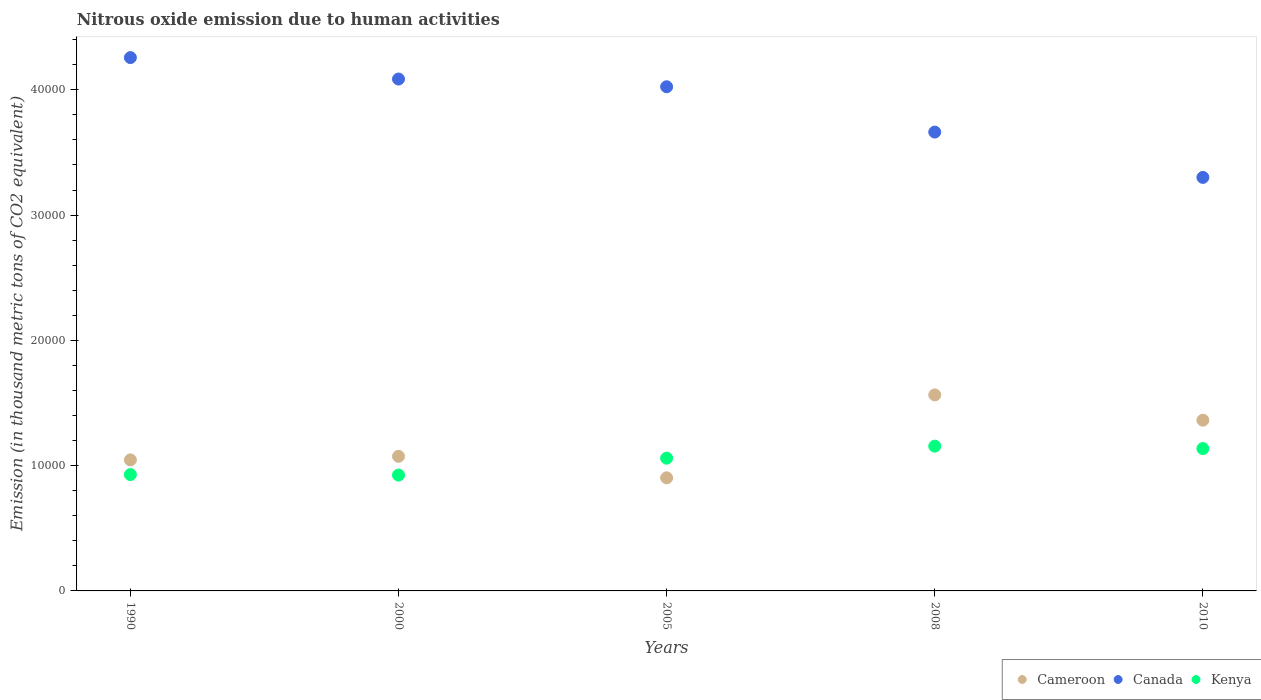Is the number of dotlines equal to the number of legend labels?
Offer a very short reply. Yes. What is the amount of nitrous oxide emitted in Kenya in 2005?
Your response must be concise. 1.06e+04. Across all years, what is the maximum amount of nitrous oxide emitted in Cameroon?
Give a very brief answer. 1.56e+04. Across all years, what is the minimum amount of nitrous oxide emitted in Canada?
Give a very brief answer. 3.30e+04. In which year was the amount of nitrous oxide emitted in Cameroon maximum?
Provide a succinct answer. 2008. In which year was the amount of nitrous oxide emitted in Kenya minimum?
Your response must be concise. 2000. What is the total amount of nitrous oxide emitted in Canada in the graph?
Offer a terse response. 1.93e+05. What is the difference between the amount of nitrous oxide emitted in Canada in 1990 and that in 2008?
Provide a short and direct response. 5946.6. What is the difference between the amount of nitrous oxide emitted in Cameroon in 2000 and the amount of nitrous oxide emitted in Kenya in 1990?
Offer a very short reply. 1460.1. What is the average amount of nitrous oxide emitted in Cameroon per year?
Your response must be concise. 1.19e+04. In the year 2005, what is the difference between the amount of nitrous oxide emitted in Kenya and amount of nitrous oxide emitted in Canada?
Keep it short and to the point. -2.96e+04. What is the ratio of the amount of nitrous oxide emitted in Kenya in 2000 to that in 2005?
Ensure brevity in your answer.  0.87. What is the difference between the highest and the second highest amount of nitrous oxide emitted in Canada?
Ensure brevity in your answer.  1712.6. What is the difference between the highest and the lowest amount of nitrous oxide emitted in Cameroon?
Give a very brief answer. 6619.5. Is it the case that in every year, the sum of the amount of nitrous oxide emitted in Canada and amount of nitrous oxide emitted in Cameroon  is greater than the amount of nitrous oxide emitted in Kenya?
Offer a very short reply. Yes. Does the amount of nitrous oxide emitted in Canada monotonically increase over the years?
Provide a succinct answer. No. Is the amount of nitrous oxide emitted in Canada strictly less than the amount of nitrous oxide emitted in Kenya over the years?
Ensure brevity in your answer.  No. How many dotlines are there?
Your answer should be compact. 3. How many years are there in the graph?
Offer a very short reply. 5. Does the graph contain any zero values?
Make the answer very short. No. Where does the legend appear in the graph?
Keep it short and to the point. Bottom right. What is the title of the graph?
Your answer should be compact. Nitrous oxide emission due to human activities. Does "Sri Lanka" appear as one of the legend labels in the graph?
Make the answer very short. No. What is the label or title of the X-axis?
Provide a succinct answer. Years. What is the label or title of the Y-axis?
Give a very brief answer. Emission (in thousand metric tons of CO2 equivalent). What is the Emission (in thousand metric tons of CO2 equivalent) of Cameroon in 1990?
Your answer should be very brief. 1.05e+04. What is the Emission (in thousand metric tons of CO2 equivalent) in Canada in 1990?
Provide a succinct answer. 4.26e+04. What is the Emission (in thousand metric tons of CO2 equivalent) in Kenya in 1990?
Make the answer very short. 9285.7. What is the Emission (in thousand metric tons of CO2 equivalent) in Cameroon in 2000?
Make the answer very short. 1.07e+04. What is the Emission (in thousand metric tons of CO2 equivalent) in Canada in 2000?
Your response must be concise. 4.09e+04. What is the Emission (in thousand metric tons of CO2 equivalent) in Kenya in 2000?
Give a very brief answer. 9247.6. What is the Emission (in thousand metric tons of CO2 equivalent) in Cameroon in 2005?
Your response must be concise. 9027.2. What is the Emission (in thousand metric tons of CO2 equivalent) in Canada in 2005?
Ensure brevity in your answer.  4.02e+04. What is the Emission (in thousand metric tons of CO2 equivalent) of Kenya in 2005?
Offer a very short reply. 1.06e+04. What is the Emission (in thousand metric tons of CO2 equivalent) of Cameroon in 2008?
Your response must be concise. 1.56e+04. What is the Emission (in thousand metric tons of CO2 equivalent) in Canada in 2008?
Your answer should be compact. 3.66e+04. What is the Emission (in thousand metric tons of CO2 equivalent) in Kenya in 2008?
Ensure brevity in your answer.  1.16e+04. What is the Emission (in thousand metric tons of CO2 equivalent) in Cameroon in 2010?
Keep it short and to the point. 1.36e+04. What is the Emission (in thousand metric tons of CO2 equivalent) in Canada in 2010?
Your answer should be very brief. 3.30e+04. What is the Emission (in thousand metric tons of CO2 equivalent) of Kenya in 2010?
Give a very brief answer. 1.14e+04. Across all years, what is the maximum Emission (in thousand metric tons of CO2 equivalent) in Cameroon?
Your answer should be compact. 1.56e+04. Across all years, what is the maximum Emission (in thousand metric tons of CO2 equivalent) in Canada?
Your answer should be very brief. 4.26e+04. Across all years, what is the maximum Emission (in thousand metric tons of CO2 equivalent) in Kenya?
Give a very brief answer. 1.16e+04. Across all years, what is the minimum Emission (in thousand metric tons of CO2 equivalent) of Cameroon?
Provide a succinct answer. 9027.2. Across all years, what is the minimum Emission (in thousand metric tons of CO2 equivalent) in Canada?
Provide a short and direct response. 3.30e+04. Across all years, what is the minimum Emission (in thousand metric tons of CO2 equivalent) of Kenya?
Provide a short and direct response. 9247.6. What is the total Emission (in thousand metric tons of CO2 equivalent) in Cameroon in the graph?
Offer a very short reply. 5.95e+04. What is the total Emission (in thousand metric tons of CO2 equivalent) in Canada in the graph?
Your answer should be very brief. 1.93e+05. What is the total Emission (in thousand metric tons of CO2 equivalent) of Kenya in the graph?
Provide a succinct answer. 5.21e+04. What is the difference between the Emission (in thousand metric tons of CO2 equivalent) in Cameroon in 1990 and that in 2000?
Keep it short and to the point. -285.5. What is the difference between the Emission (in thousand metric tons of CO2 equivalent) in Canada in 1990 and that in 2000?
Make the answer very short. 1712.6. What is the difference between the Emission (in thousand metric tons of CO2 equivalent) in Kenya in 1990 and that in 2000?
Make the answer very short. 38.1. What is the difference between the Emission (in thousand metric tons of CO2 equivalent) of Cameroon in 1990 and that in 2005?
Offer a terse response. 1433.1. What is the difference between the Emission (in thousand metric tons of CO2 equivalent) of Canada in 1990 and that in 2005?
Offer a terse response. 2329.2. What is the difference between the Emission (in thousand metric tons of CO2 equivalent) of Kenya in 1990 and that in 2005?
Your answer should be compact. -1310.7. What is the difference between the Emission (in thousand metric tons of CO2 equivalent) in Cameroon in 1990 and that in 2008?
Offer a terse response. -5186.4. What is the difference between the Emission (in thousand metric tons of CO2 equivalent) of Canada in 1990 and that in 2008?
Provide a succinct answer. 5946.6. What is the difference between the Emission (in thousand metric tons of CO2 equivalent) in Kenya in 1990 and that in 2008?
Give a very brief answer. -2270.6. What is the difference between the Emission (in thousand metric tons of CO2 equivalent) in Cameroon in 1990 and that in 2010?
Your answer should be very brief. -3167.4. What is the difference between the Emission (in thousand metric tons of CO2 equivalent) of Canada in 1990 and that in 2010?
Your answer should be compact. 9564.7. What is the difference between the Emission (in thousand metric tons of CO2 equivalent) of Kenya in 1990 and that in 2010?
Provide a short and direct response. -2078.5. What is the difference between the Emission (in thousand metric tons of CO2 equivalent) of Cameroon in 2000 and that in 2005?
Keep it short and to the point. 1718.6. What is the difference between the Emission (in thousand metric tons of CO2 equivalent) of Canada in 2000 and that in 2005?
Your response must be concise. 616.6. What is the difference between the Emission (in thousand metric tons of CO2 equivalent) in Kenya in 2000 and that in 2005?
Offer a very short reply. -1348.8. What is the difference between the Emission (in thousand metric tons of CO2 equivalent) of Cameroon in 2000 and that in 2008?
Provide a short and direct response. -4900.9. What is the difference between the Emission (in thousand metric tons of CO2 equivalent) of Canada in 2000 and that in 2008?
Ensure brevity in your answer.  4234. What is the difference between the Emission (in thousand metric tons of CO2 equivalent) in Kenya in 2000 and that in 2008?
Offer a terse response. -2308.7. What is the difference between the Emission (in thousand metric tons of CO2 equivalent) in Cameroon in 2000 and that in 2010?
Ensure brevity in your answer.  -2881.9. What is the difference between the Emission (in thousand metric tons of CO2 equivalent) in Canada in 2000 and that in 2010?
Ensure brevity in your answer.  7852.1. What is the difference between the Emission (in thousand metric tons of CO2 equivalent) of Kenya in 2000 and that in 2010?
Your answer should be compact. -2116.6. What is the difference between the Emission (in thousand metric tons of CO2 equivalent) in Cameroon in 2005 and that in 2008?
Offer a very short reply. -6619.5. What is the difference between the Emission (in thousand metric tons of CO2 equivalent) in Canada in 2005 and that in 2008?
Ensure brevity in your answer.  3617.4. What is the difference between the Emission (in thousand metric tons of CO2 equivalent) in Kenya in 2005 and that in 2008?
Keep it short and to the point. -959.9. What is the difference between the Emission (in thousand metric tons of CO2 equivalent) of Cameroon in 2005 and that in 2010?
Give a very brief answer. -4600.5. What is the difference between the Emission (in thousand metric tons of CO2 equivalent) of Canada in 2005 and that in 2010?
Keep it short and to the point. 7235.5. What is the difference between the Emission (in thousand metric tons of CO2 equivalent) in Kenya in 2005 and that in 2010?
Offer a terse response. -767.8. What is the difference between the Emission (in thousand metric tons of CO2 equivalent) in Cameroon in 2008 and that in 2010?
Keep it short and to the point. 2019. What is the difference between the Emission (in thousand metric tons of CO2 equivalent) of Canada in 2008 and that in 2010?
Ensure brevity in your answer.  3618.1. What is the difference between the Emission (in thousand metric tons of CO2 equivalent) in Kenya in 2008 and that in 2010?
Offer a terse response. 192.1. What is the difference between the Emission (in thousand metric tons of CO2 equivalent) of Cameroon in 1990 and the Emission (in thousand metric tons of CO2 equivalent) of Canada in 2000?
Your answer should be compact. -3.04e+04. What is the difference between the Emission (in thousand metric tons of CO2 equivalent) in Cameroon in 1990 and the Emission (in thousand metric tons of CO2 equivalent) in Kenya in 2000?
Offer a very short reply. 1212.7. What is the difference between the Emission (in thousand metric tons of CO2 equivalent) in Canada in 1990 and the Emission (in thousand metric tons of CO2 equivalent) in Kenya in 2000?
Offer a very short reply. 3.33e+04. What is the difference between the Emission (in thousand metric tons of CO2 equivalent) in Cameroon in 1990 and the Emission (in thousand metric tons of CO2 equivalent) in Canada in 2005?
Your answer should be very brief. -2.98e+04. What is the difference between the Emission (in thousand metric tons of CO2 equivalent) of Cameroon in 1990 and the Emission (in thousand metric tons of CO2 equivalent) of Kenya in 2005?
Give a very brief answer. -136.1. What is the difference between the Emission (in thousand metric tons of CO2 equivalent) of Canada in 1990 and the Emission (in thousand metric tons of CO2 equivalent) of Kenya in 2005?
Make the answer very short. 3.20e+04. What is the difference between the Emission (in thousand metric tons of CO2 equivalent) of Cameroon in 1990 and the Emission (in thousand metric tons of CO2 equivalent) of Canada in 2008?
Offer a terse response. -2.62e+04. What is the difference between the Emission (in thousand metric tons of CO2 equivalent) in Cameroon in 1990 and the Emission (in thousand metric tons of CO2 equivalent) in Kenya in 2008?
Provide a short and direct response. -1096. What is the difference between the Emission (in thousand metric tons of CO2 equivalent) in Canada in 1990 and the Emission (in thousand metric tons of CO2 equivalent) in Kenya in 2008?
Offer a very short reply. 3.10e+04. What is the difference between the Emission (in thousand metric tons of CO2 equivalent) of Cameroon in 1990 and the Emission (in thousand metric tons of CO2 equivalent) of Canada in 2010?
Your answer should be compact. -2.25e+04. What is the difference between the Emission (in thousand metric tons of CO2 equivalent) in Cameroon in 1990 and the Emission (in thousand metric tons of CO2 equivalent) in Kenya in 2010?
Your answer should be compact. -903.9. What is the difference between the Emission (in thousand metric tons of CO2 equivalent) in Canada in 1990 and the Emission (in thousand metric tons of CO2 equivalent) in Kenya in 2010?
Provide a short and direct response. 3.12e+04. What is the difference between the Emission (in thousand metric tons of CO2 equivalent) in Cameroon in 2000 and the Emission (in thousand metric tons of CO2 equivalent) in Canada in 2005?
Your answer should be compact. -2.95e+04. What is the difference between the Emission (in thousand metric tons of CO2 equivalent) in Cameroon in 2000 and the Emission (in thousand metric tons of CO2 equivalent) in Kenya in 2005?
Offer a terse response. 149.4. What is the difference between the Emission (in thousand metric tons of CO2 equivalent) in Canada in 2000 and the Emission (in thousand metric tons of CO2 equivalent) in Kenya in 2005?
Your answer should be very brief. 3.03e+04. What is the difference between the Emission (in thousand metric tons of CO2 equivalent) of Cameroon in 2000 and the Emission (in thousand metric tons of CO2 equivalent) of Canada in 2008?
Your answer should be compact. -2.59e+04. What is the difference between the Emission (in thousand metric tons of CO2 equivalent) in Cameroon in 2000 and the Emission (in thousand metric tons of CO2 equivalent) in Kenya in 2008?
Your response must be concise. -810.5. What is the difference between the Emission (in thousand metric tons of CO2 equivalent) of Canada in 2000 and the Emission (in thousand metric tons of CO2 equivalent) of Kenya in 2008?
Ensure brevity in your answer.  2.93e+04. What is the difference between the Emission (in thousand metric tons of CO2 equivalent) in Cameroon in 2000 and the Emission (in thousand metric tons of CO2 equivalent) in Canada in 2010?
Make the answer very short. -2.23e+04. What is the difference between the Emission (in thousand metric tons of CO2 equivalent) of Cameroon in 2000 and the Emission (in thousand metric tons of CO2 equivalent) of Kenya in 2010?
Offer a very short reply. -618.4. What is the difference between the Emission (in thousand metric tons of CO2 equivalent) of Canada in 2000 and the Emission (in thousand metric tons of CO2 equivalent) of Kenya in 2010?
Provide a succinct answer. 2.95e+04. What is the difference between the Emission (in thousand metric tons of CO2 equivalent) of Cameroon in 2005 and the Emission (in thousand metric tons of CO2 equivalent) of Canada in 2008?
Offer a terse response. -2.76e+04. What is the difference between the Emission (in thousand metric tons of CO2 equivalent) in Cameroon in 2005 and the Emission (in thousand metric tons of CO2 equivalent) in Kenya in 2008?
Your answer should be compact. -2529.1. What is the difference between the Emission (in thousand metric tons of CO2 equivalent) in Canada in 2005 and the Emission (in thousand metric tons of CO2 equivalent) in Kenya in 2008?
Your answer should be very brief. 2.87e+04. What is the difference between the Emission (in thousand metric tons of CO2 equivalent) of Cameroon in 2005 and the Emission (in thousand metric tons of CO2 equivalent) of Canada in 2010?
Offer a very short reply. -2.40e+04. What is the difference between the Emission (in thousand metric tons of CO2 equivalent) of Cameroon in 2005 and the Emission (in thousand metric tons of CO2 equivalent) of Kenya in 2010?
Your answer should be compact. -2337. What is the difference between the Emission (in thousand metric tons of CO2 equivalent) in Canada in 2005 and the Emission (in thousand metric tons of CO2 equivalent) in Kenya in 2010?
Make the answer very short. 2.89e+04. What is the difference between the Emission (in thousand metric tons of CO2 equivalent) of Cameroon in 2008 and the Emission (in thousand metric tons of CO2 equivalent) of Canada in 2010?
Offer a very short reply. -1.74e+04. What is the difference between the Emission (in thousand metric tons of CO2 equivalent) in Cameroon in 2008 and the Emission (in thousand metric tons of CO2 equivalent) in Kenya in 2010?
Provide a succinct answer. 4282.5. What is the difference between the Emission (in thousand metric tons of CO2 equivalent) in Canada in 2008 and the Emission (in thousand metric tons of CO2 equivalent) in Kenya in 2010?
Provide a succinct answer. 2.53e+04. What is the average Emission (in thousand metric tons of CO2 equivalent) of Cameroon per year?
Provide a short and direct response. 1.19e+04. What is the average Emission (in thousand metric tons of CO2 equivalent) of Canada per year?
Offer a terse response. 3.87e+04. What is the average Emission (in thousand metric tons of CO2 equivalent) in Kenya per year?
Offer a terse response. 1.04e+04. In the year 1990, what is the difference between the Emission (in thousand metric tons of CO2 equivalent) in Cameroon and Emission (in thousand metric tons of CO2 equivalent) in Canada?
Give a very brief answer. -3.21e+04. In the year 1990, what is the difference between the Emission (in thousand metric tons of CO2 equivalent) of Cameroon and Emission (in thousand metric tons of CO2 equivalent) of Kenya?
Keep it short and to the point. 1174.6. In the year 1990, what is the difference between the Emission (in thousand metric tons of CO2 equivalent) in Canada and Emission (in thousand metric tons of CO2 equivalent) in Kenya?
Your answer should be very brief. 3.33e+04. In the year 2000, what is the difference between the Emission (in thousand metric tons of CO2 equivalent) in Cameroon and Emission (in thousand metric tons of CO2 equivalent) in Canada?
Offer a terse response. -3.01e+04. In the year 2000, what is the difference between the Emission (in thousand metric tons of CO2 equivalent) in Cameroon and Emission (in thousand metric tons of CO2 equivalent) in Kenya?
Offer a terse response. 1498.2. In the year 2000, what is the difference between the Emission (in thousand metric tons of CO2 equivalent) in Canada and Emission (in thousand metric tons of CO2 equivalent) in Kenya?
Offer a very short reply. 3.16e+04. In the year 2005, what is the difference between the Emission (in thousand metric tons of CO2 equivalent) of Cameroon and Emission (in thousand metric tons of CO2 equivalent) of Canada?
Give a very brief answer. -3.12e+04. In the year 2005, what is the difference between the Emission (in thousand metric tons of CO2 equivalent) in Cameroon and Emission (in thousand metric tons of CO2 equivalent) in Kenya?
Your answer should be compact. -1569.2. In the year 2005, what is the difference between the Emission (in thousand metric tons of CO2 equivalent) in Canada and Emission (in thousand metric tons of CO2 equivalent) in Kenya?
Keep it short and to the point. 2.96e+04. In the year 2008, what is the difference between the Emission (in thousand metric tons of CO2 equivalent) of Cameroon and Emission (in thousand metric tons of CO2 equivalent) of Canada?
Offer a very short reply. -2.10e+04. In the year 2008, what is the difference between the Emission (in thousand metric tons of CO2 equivalent) in Cameroon and Emission (in thousand metric tons of CO2 equivalent) in Kenya?
Make the answer very short. 4090.4. In the year 2008, what is the difference between the Emission (in thousand metric tons of CO2 equivalent) of Canada and Emission (in thousand metric tons of CO2 equivalent) of Kenya?
Keep it short and to the point. 2.51e+04. In the year 2010, what is the difference between the Emission (in thousand metric tons of CO2 equivalent) in Cameroon and Emission (in thousand metric tons of CO2 equivalent) in Canada?
Your response must be concise. -1.94e+04. In the year 2010, what is the difference between the Emission (in thousand metric tons of CO2 equivalent) in Cameroon and Emission (in thousand metric tons of CO2 equivalent) in Kenya?
Offer a very short reply. 2263.5. In the year 2010, what is the difference between the Emission (in thousand metric tons of CO2 equivalent) of Canada and Emission (in thousand metric tons of CO2 equivalent) of Kenya?
Ensure brevity in your answer.  2.16e+04. What is the ratio of the Emission (in thousand metric tons of CO2 equivalent) of Cameroon in 1990 to that in 2000?
Keep it short and to the point. 0.97. What is the ratio of the Emission (in thousand metric tons of CO2 equivalent) of Canada in 1990 to that in 2000?
Ensure brevity in your answer.  1.04. What is the ratio of the Emission (in thousand metric tons of CO2 equivalent) of Kenya in 1990 to that in 2000?
Your response must be concise. 1. What is the ratio of the Emission (in thousand metric tons of CO2 equivalent) of Cameroon in 1990 to that in 2005?
Ensure brevity in your answer.  1.16. What is the ratio of the Emission (in thousand metric tons of CO2 equivalent) in Canada in 1990 to that in 2005?
Make the answer very short. 1.06. What is the ratio of the Emission (in thousand metric tons of CO2 equivalent) in Kenya in 1990 to that in 2005?
Provide a short and direct response. 0.88. What is the ratio of the Emission (in thousand metric tons of CO2 equivalent) in Cameroon in 1990 to that in 2008?
Make the answer very short. 0.67. What is the ratio of the Emission (in thousand metric tons of CO2 equivalent) of Canada in 1990 to that in 2008?
Your response must be concise. 1.16. What is the ratio of the Emission (in thousand metric tons of CO2 equivalent) of Kenya in 1990 to that in 2008?
Provide a short and direct response. 0.8. What is the ratio of the Emission (in thousand metric tons of CO2 equivalent) of Cameroon in 1990 to that in 2010?
Offer a terse response. 0.77. What is the ratio of the Emission (in thousand metric tons of CO2 equivalent) of Canada in 1990 to that in 2010?
Ensure brevity in your answer.  1.29. What is the ratio of the Emission (in thousand metric tons of CO2 equivalent) of Kenya in 1990 to that in 2010?
Offer a very short reply. 0.82. What is the ratio of the Emission (in thousand metric tons of CO2 equivalent) of Cameroon in 2000 to that in 2005?
Give a very brief answer. 1.19. What is the ratio of the Emission (in thousand metric tons of CO2 equivalent) in Canada in 2000 to that in 2005?
Provide a succinct answer. 1.02. What is the ratio of the Emission (in thousand metric tons of CO2 equivalent) of Kenya in 2000 to that in 2005?
Your answer should be compact. 0.87. What is the ratio of the Emission (in thousand metric tons of CO2 equivalent) in Cameroon in 2000 to that in 2008?
Provide a short and direct response. 0.69. What is the ratio of the Emission (in thousand metric tons of CO2 equivalent) of Canada in 2000 to that in 2008?
Make the answer very short. 1.12. What is the ratio of the Emission (in thousand metric tons of CO2 equivalent) of Kenya in 2000 to that in 2008?
Ensure brevity in your answer.  0.8. What is the ratio of the Emission (in thousand metric tons of CO2 equivalent) in Cameroon in 2000 to that in 2010?
Provide a succinct answer. 0.79. What is the ratio of the Emission (in thousand metric tons of CO2 equivalent) of Canada in 2000 to that in 2010?
Provide a short and direct response. 1.24. What is the ratio of the Emission (in thousand metric tons of CO2 equivalent) of Kenya in 2000 to that in 2010?
Offer a very short reply. 0.81. What is the ratio of the Emission (in thousand metric tons of CO2 equivalent) of Cameroon in 2005 to that in 2008?
Ensure brevity in your answer.  0.58. What is the ratio of the Emission (in thousand metric tons of CO2 equivalent) of Canada in 2005 to that in 2008?
Ensure brevity in your answer.  1.1. What is the ratio of the Emission (in thousand metric tons of CO2 equivalent) in Kenya in 2005 to that in 2008?
Give a very brief answer. 0.92. What is the ratio of the Emission (in thousand metric tons of CO2 equivalent) in Cameroon in 2005 to that in 2010?
Your answer should be very brief. 0.66. What is the ratio of the Emission (in thousand metric tons of CO2 equivalent) in Canada in 2005 to that in 2010?
Provide a short and direct response. 1.22. What is the ratio of the Emission (in thousand metric tons of CO2 equivalent) of Kenya in 2005 to that in 2010?
Provide a succinct answer. 0.93. What is the ratio of the Emission (in thousand metric tons of CO2 equivalent) in Cameroon in 2008 to that in 2010?
Ensure brevity in your answer.  1.15. What is the ratio of the Emission (in thousand metric tons of CO2 equivalent) of Canada in 2008 to that in 2010?
Make the answer very short. 1.11. What is the ratio of the Emission (in thousand metric tons of CO2 equivalent) of Kenya in 2008 to that in 2010?
Ensure brevity in your answer.  1.02. What is the difference between the highest and the second highest Emission (in thousand metric tons of CO2 equivalent) in Cameroon?
Keep it short and to the point. 2019. What is the difference between the highest and the second highest Emission (in thousand metric tons of CO2 equivalent) in Canada?
Provide a short and direct response. 1712.6. What is the difference between the highest and the second highest Emission (in thousand metric tons of CO2 equivalent) of Kenya?
Ensure brevity in your answer.  192.1. What is the difference between the highest and the lowest Emission (in thousand metric tons of CO2 equivalent) of Cameroon?
Your answer should be very brief. 6619.5. What is the difference between the highest and the lowest Emission (in thousand metric tons of CO2 equivalent) in Canada?
Keep it short and to the point. 9564.7. What is the difference between the highest and the lowest Emission (in thousand metric tons of CO2 equivalent) of Kenya?
Keep it short and to the point. 2308.7. 